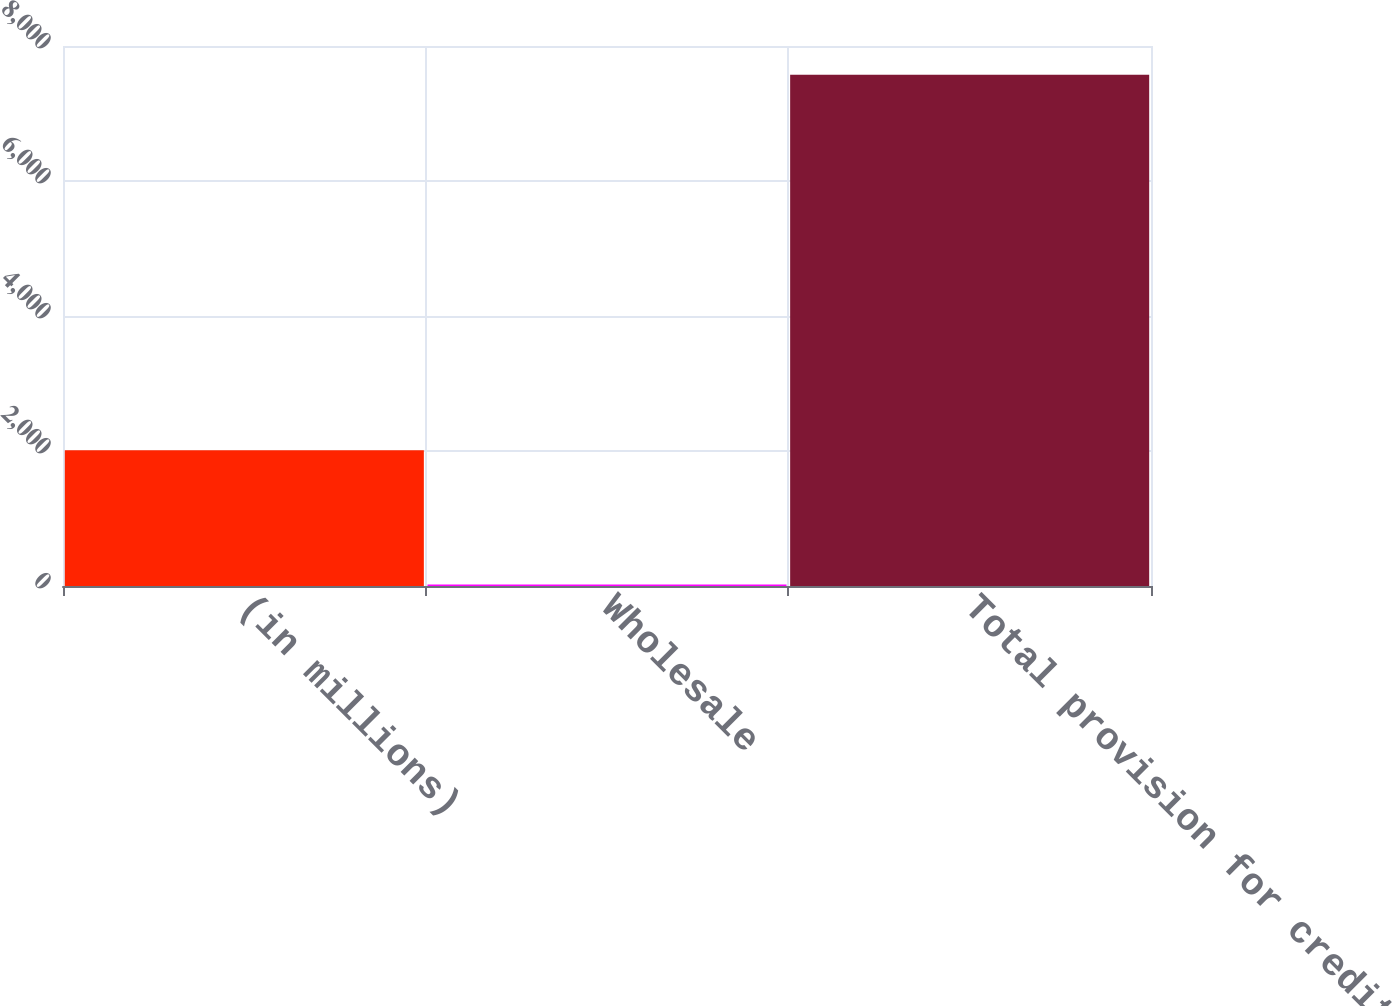Convert chart. <chart><loc_0><loc_0><loc_500><loc_500><bar_chart><fcel>(in millions)<fcel>Wholesale<fcel>Total provision for credit<nl><fcel>2011<fcel>23<fcel>7574<nl></chart> 